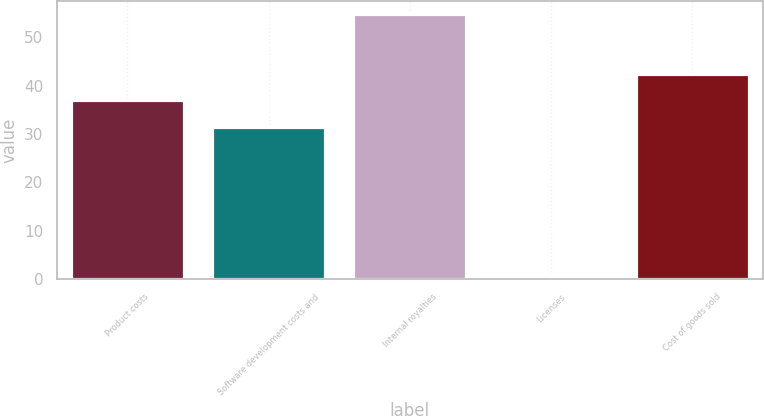Convert chart to OTSL. <chart><loc_0><loc_0><loc_500><loc_500><bar_chart><fcel>Product costs<fcel>Software development costs and<fcel>Internal royalties<fcel>Licenses<fcel>Cost of goods sold<nl><fcel>36.92<fcel>31.5<fcel>54.8<fcel>0.6<fcel>42.34<nl></chart> 